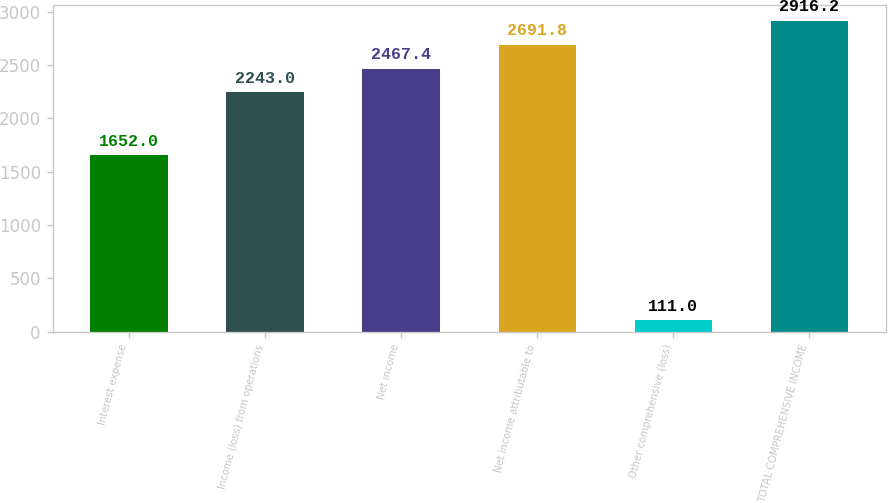<chart> <loc_0><loc_0><loc_500><loc_500><bar_chart><fcel>Interest expense<fcel>Income (loss) from operations<fcel>Net income<fcel>Net income attributable to<fcel>Other comprehensive (loss)<fcel>TOTAL COMPREHENSIVE INCOME<nl><fcel>1652<fcel>2243<fcel>2467.4<fcel>2691.8<fcel>111<fcel>2916.2<nl></chart> 